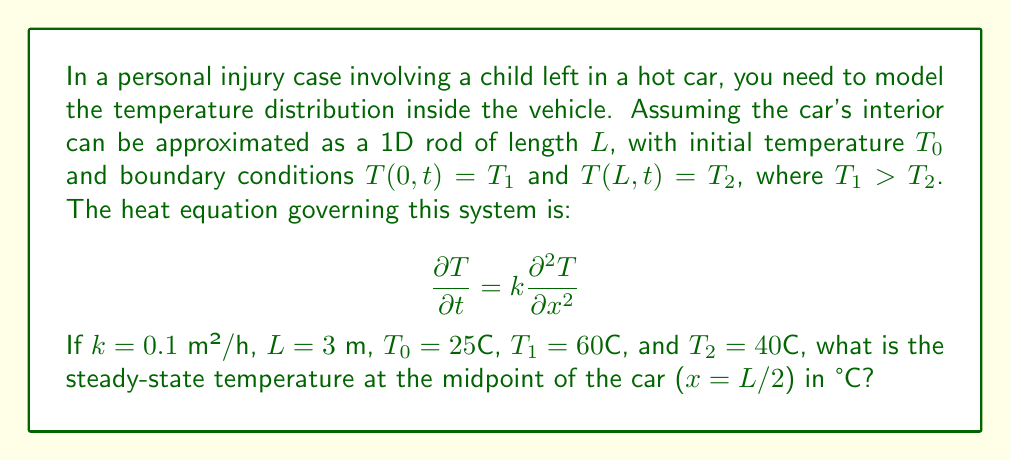Can you solve this math problem? To solve this problem, we'll follow these steps:

1) For the steady-state solution, the temperature doesn't change with time, so $\frac{\partial T}{\partial t} = 0$. The heat equation reduces to:

   $$0 = k\frac{\partial^2 T}{\partial x^2}$$

2) Integrating twice with respect to $x$:

   $$T(x) = ax + b$$

   where $a$ and $b$ are constants to be determined from the boundary conditions.

3) Apply the boundary conditions:
   
   At $x = 0$: $T(0) = T_1 = 60°C = b$
   At $x = L$: $T(L) = T_2 = 40°C = aL + b$

4) Solve for $a$:

   $$a = \frac{T_2 - T_1}{L} = \frac{40 - 60}{3} = -\frac{20}{3}$$

5) The steady-state temperature distribution is:

   $$T(x) = -\frac{20}{3}x + 60$$

6) At the midpoint, $x = L/2 = 1.5$ m:

   $$T(1.5) = -\frac{20}{3}(1.5) + 60 = -10 + 60 = 50°C$$

Therefore, the steady-state temperature at the midpoint of the car is 50°C.
Answer: 50°C 